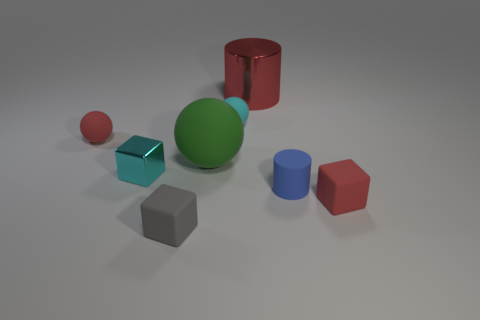What number of rubber things have the same color as the big rubber ball?
Provide a short and direct response. 0. What number of things are in front of the large red object and left of the matte cylinder?
Provide a succinct answer. 5. The cyan metallic object that is the same size as the gray block is what shape?
Provide a short and direct response. Cube. How big is the cyan metal block?
Your answer should be compact. Small. What material is the cyan object to the right of the big thing to the left of the tiny sphere on the right side of the cyan cube?
Offer a very short reply. Rubber. The small cylinder that is the same material as the red sphere is what color?
Give a very brief answer. Blue. There is a block that is right of the metallic thing that is to the right of the metal cube; what number of tiny blue cylinders are behind it?
Offer a terse response. 1. There is a object that is the same color as the tiny metallic cube; what material is it?
Ensure brevity in your answer.  Rubber. What number of things are things in front of the green sphere or tiny things?
Your answer should be very brief. 6. There is a ball that is to the left of the shiny block; is it the same color as the big metal cylinder?
Keep it short and to the point. Yes. 